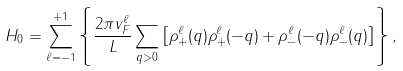<formula> <loc_0><loc_0><loc_500><loc_500>H _ { 0 } = \sum _ { \ell = - 1 } ^ { + 1 } \left \{ \frac { 2 \pi v ^ { \ell } _ { F } } { L } \sum _ { q > 0 } \left [ \rho ^ { \ell } _ { + } ( q ) \rho ^ { \ell } _ { + } ( - q ) + \rho ^ { \ell } _ { - } ( - q ) \rho ^ { \ell } _ { - } ( q ) \right ] \right \} ,</formula> 